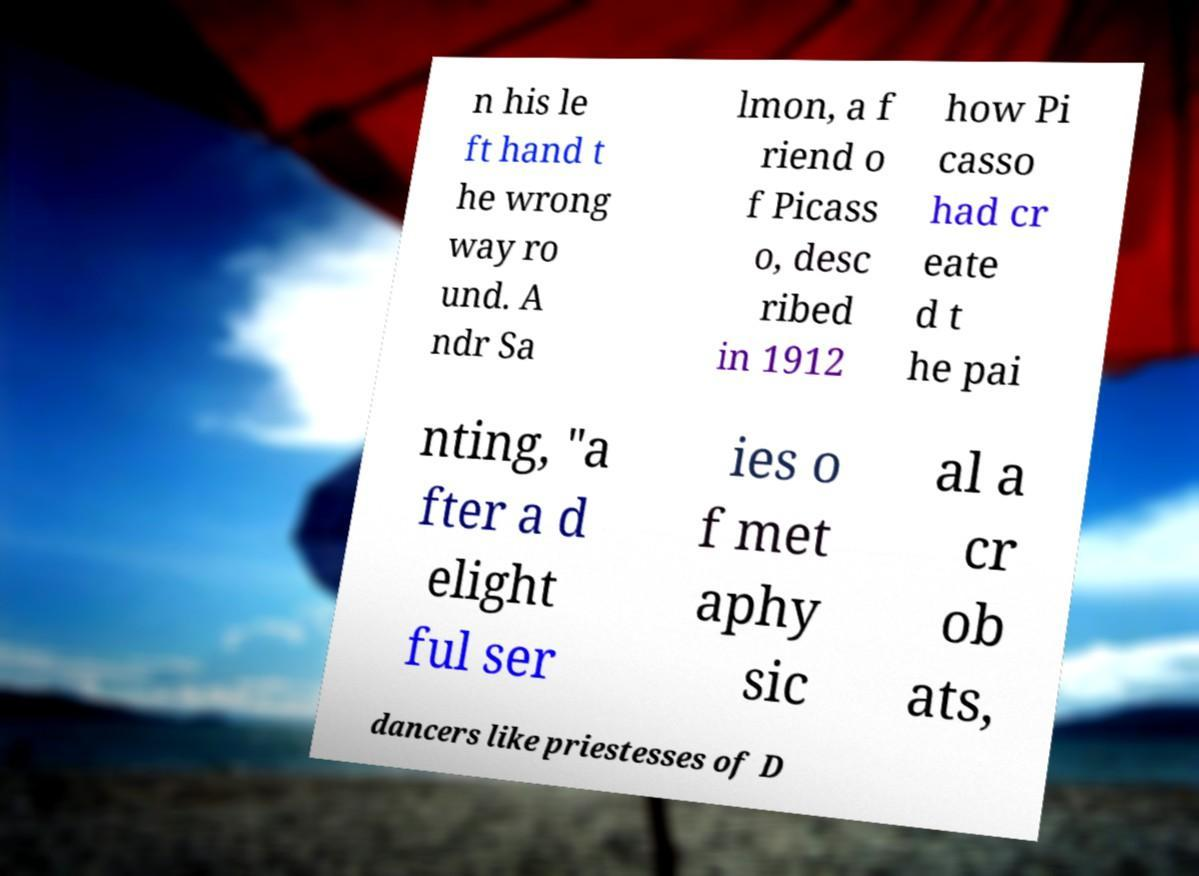Please read and relay the text visible in this image. What does it say? n his le ft hand t he wrong way ro und. A ndr Sa lmon, a f riend o f Picass o, desc ribed in 1912 how Pi casso had cr eate d t he pai nting, "a fter a d elight ful ser ies o f met aphy sic al a cr ob ats, dancers like priestesses of D 